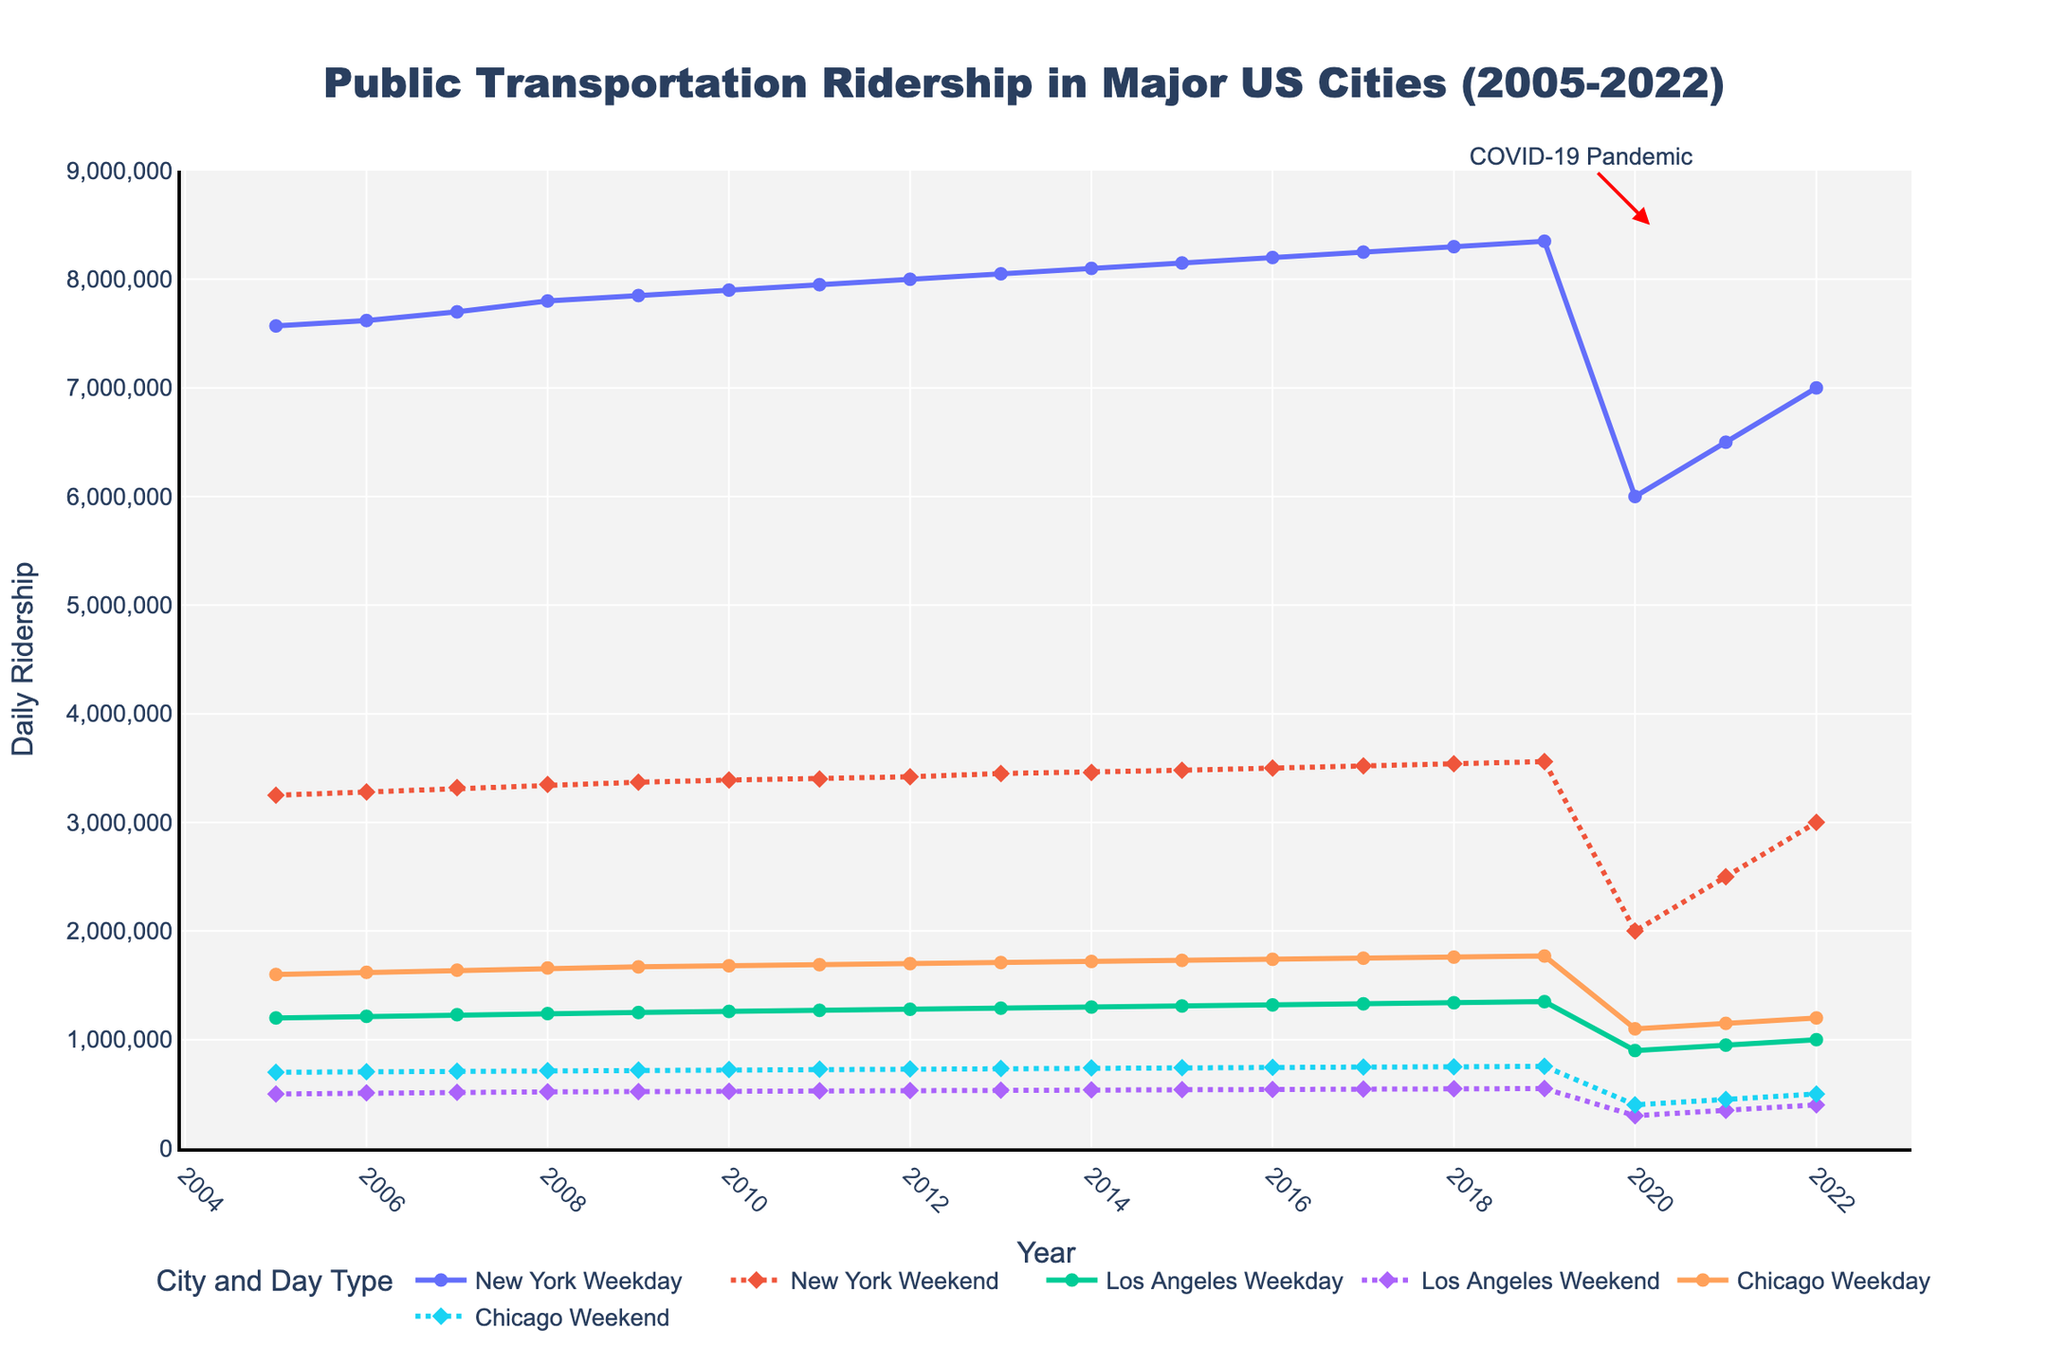What is the title of the figure? The title is prominently displayed at the top of the figure, indicating the subject matter and time frame of the plot. It helps viewers immediately understand what the data represents.
Answer: Public Transportation Ridership in Major US Cities (2005-2022) What are the x-axis and y-axis labels? The x-axis and y-axis labels are essential components of the figure that describe what the axes represent. They make it clear what data the viewer is looking at along each axis.
Answer: The x-axis is labeled "Year" and the y-axis is labeled "Daily Ridership" How did the COVID-19 pandemic affect public transportation ridership in New York? To answer this question, observe the annotations and the marked decline in ridership during the pandemic years on the plot.
Answer: The ridership in New York dropped significantly in 2020; weekday ridership fell to 6,000,000 and weekend ridership to 2,000,000 Compare weekday ridership in New York and Los Angeles in 2015. To compare values, look at the specific points for each city in 2015 on the figure and compare their positions along the y-axis.
Answer: New York had 8,150,000 and Los Angeles had 1,310,000 What is the trend in weekday ridership for Chicago from 2005 to 2022? Identify the line representing Chicago's weekday ridership and observe its trajectory over the years.
Answer: Weekday ridership in Chicago generally increased until 2019, then decreased in 2020, and started rising again in 2021 and 2022 Which city had the highest weekend ridership in 2016? Compare the weekend ridership data points for all cities in 2016 by looking at the plot's markers for that year.
Answer: New York had the highest weekend ridership in 2016 with 3,500,000 By how much did Los Angeles' weekday ridership change from 2019 to 2020? Subtract the 2020 value from the 2019 value for Los Angeles' weekday ridership.
Answer: It decreased by 450,000 (from 1,350,000 in 2019 to 900,000 in 2020) What distinct pattern can be seen when comparing weekday and weekend ridership across all cities? Notice the lines and markers representing both weekday and weekend ridership and identify any consistent differences.
Answer: Weekday ridership is consistently higher than weekend ridership for all cities across the entire time period How did public transportation ridership change in 2022 compared to 2021 for New York? Compare the data points for New York in 2021 and 2022 for both weekday and weekend ridership.
Answer: Weekday ridership increased by 500,000 (from 6,500,000 to 7,000,000) and weekend ridership increased by 500,000 (from 2,500,000 to 3,000,000) 